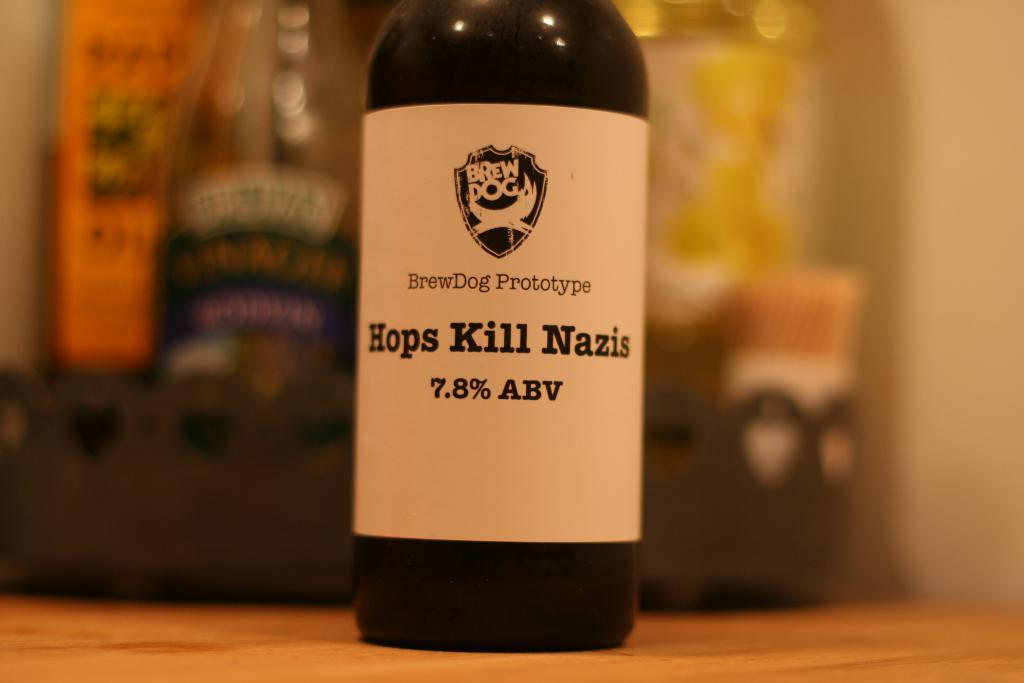Provide a one-sentence caption for the provided image. A bottle of alcohol with the words Hops Kill Nazis on the label,. 